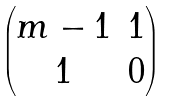Convert formula to latex. <formula><loc_0><loc_0><loc_500><loc_500>\begin{pmatrix} m - 1 & 1 \\ 1 & 0 \end{pmatrix}</formula> 